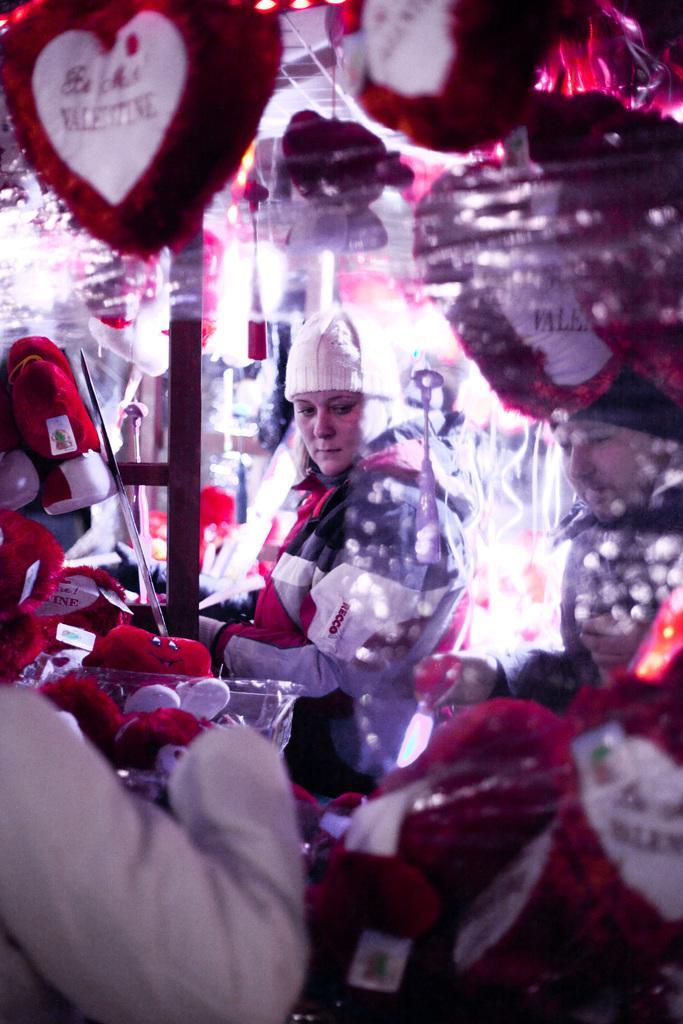Who are the people in the image? There is a woman and a man in the image. What are the woman and man doing in the image? The woman and man are standing. What can be seen in the image besides the woman and man? There are many toys in the shape of a heart in the image. What is unique about the toys in the image? The toys have text on them. What type of nose can be seen on the calculator in the image? There is no calculator present in the image, so it is not possible to determine what type of nose might be on it. 